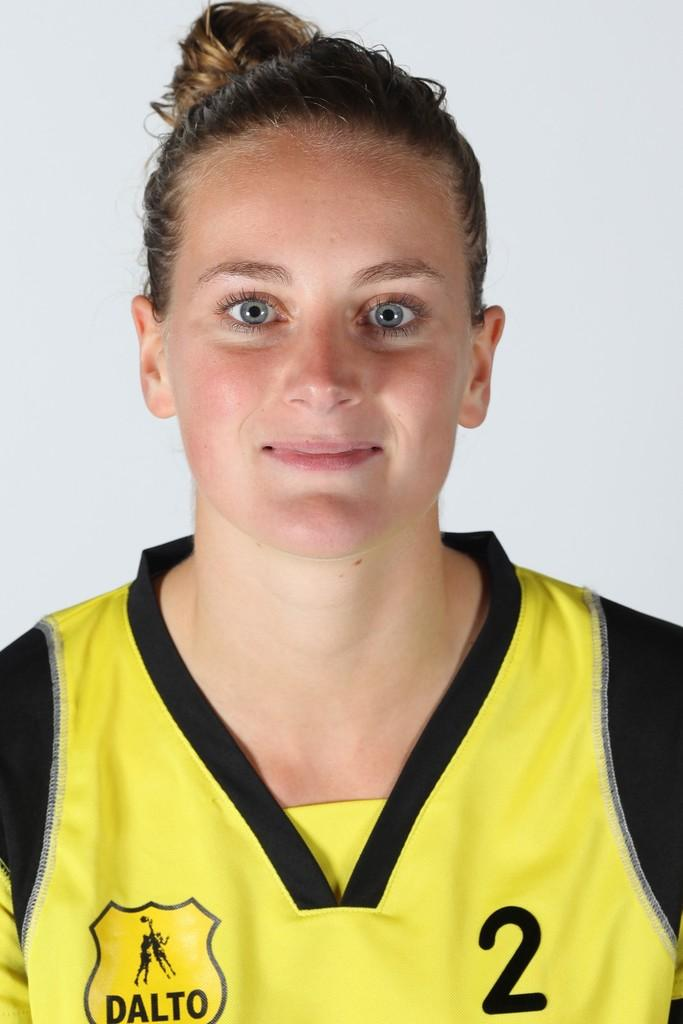<image>
Create a compact narrative representing the image presented. a female player from the team Dalto posing for a photo 